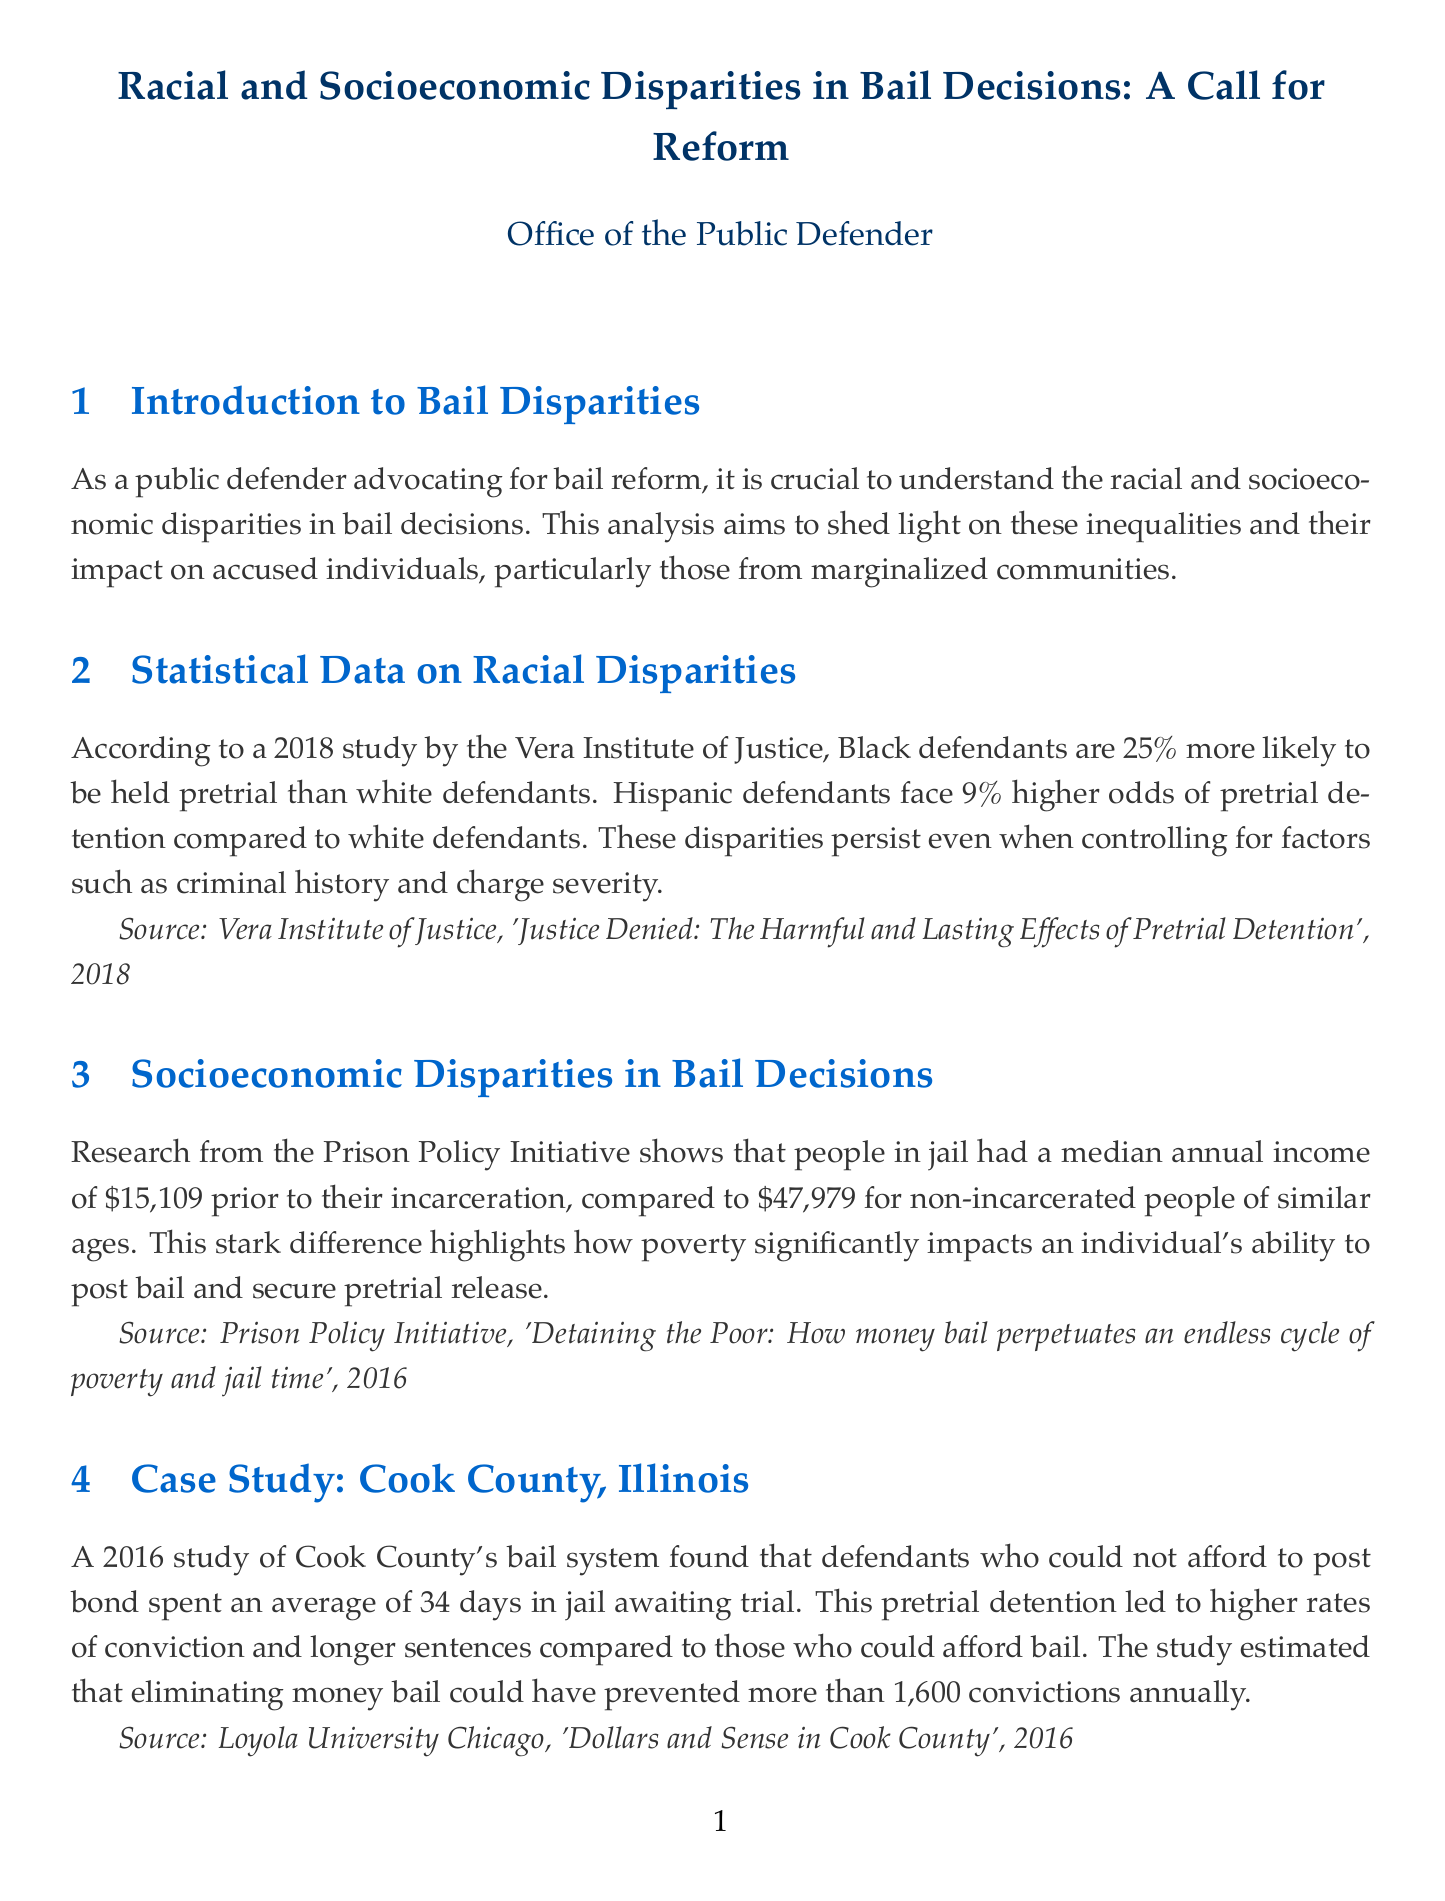What percentage more likely are Black defendants to be held pretrial than white defendants? The percentage is found in the section on statistical data about racial disparities, which states Black defendants are 25% more likely to be held pretrial than white defendants.
Answer: 25% What is the median annual income of people in jail prior to incarceration? This information is presented in the section discussing socioeconomic disparities, which notes a median annual income of $15,109 for incarcerated individuals.
Answer: $15,109 How many days do defendants spend in jail on average if they cannot afford to post bond in Cook County? The case study in Cook County reveals that defendants who could not afford bail spent an average of 34 days in jail awaiting trial.
Answer: 34 days What major reform did New Jersey implement in 2017 regarding bail? The report outlines that New Jersey's Bail Reform and Speedy Trial Act largely eliminated cash bail and implemented a risk assessment tool.
Answer: Cash bail elimination What is the percentage decrease in New Jersey's pretrial jail population from 2015 to 2018? This statistic is found in the section about successful bail reform initiatives; the pretrial jail population decreased by 44%.
Answer: 44% According to the Arnold Foundation, low-risk defendants held for 2-3 days are more likely to commit new crimes before trial by what percentage compared to those held for less than 24 hours? The impact of pretrial detention on recidivism is discussed, stating that these defendants are 40% more likely to commit new crimes.
Answer: 40% What is one key recommendation for bail reform mentioned in the report? The recommendations section lists various reforms, including the implementation of risk assessment tools to replace cash bail.
Answer: Risk assessment tools Which organization conducted the study that found racial disparities in bail decisions? This detail is found in the section on statistical data, attributing the study to the Vera Institute of Justice.
Answer: Vera Institute of Justice 